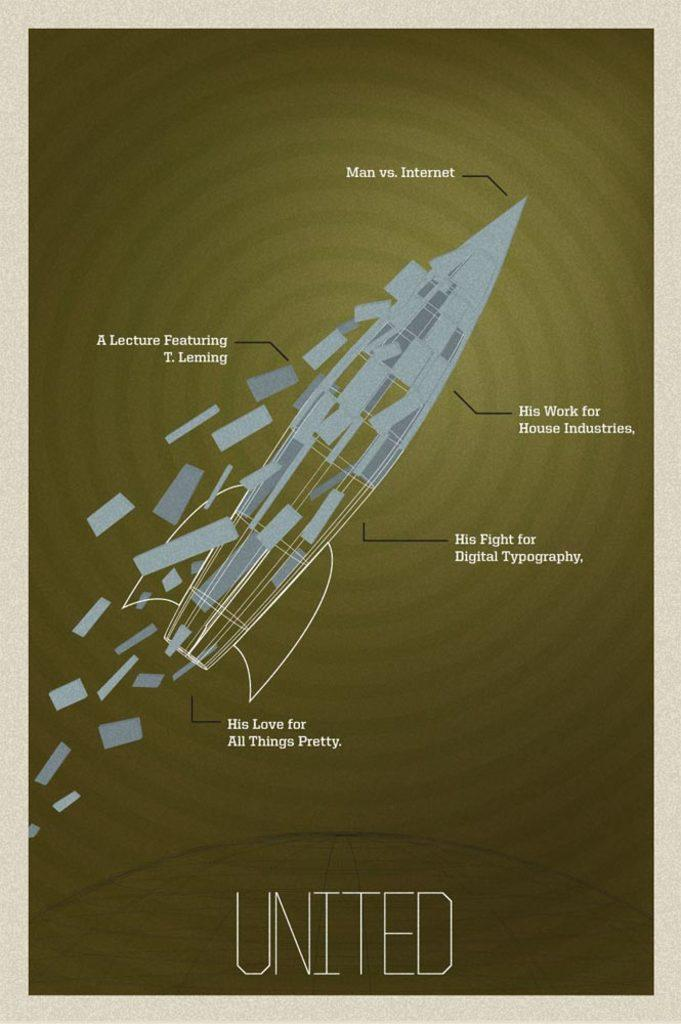<image>
Summarize the visual content of the image. a poster that has man vs internet on it 